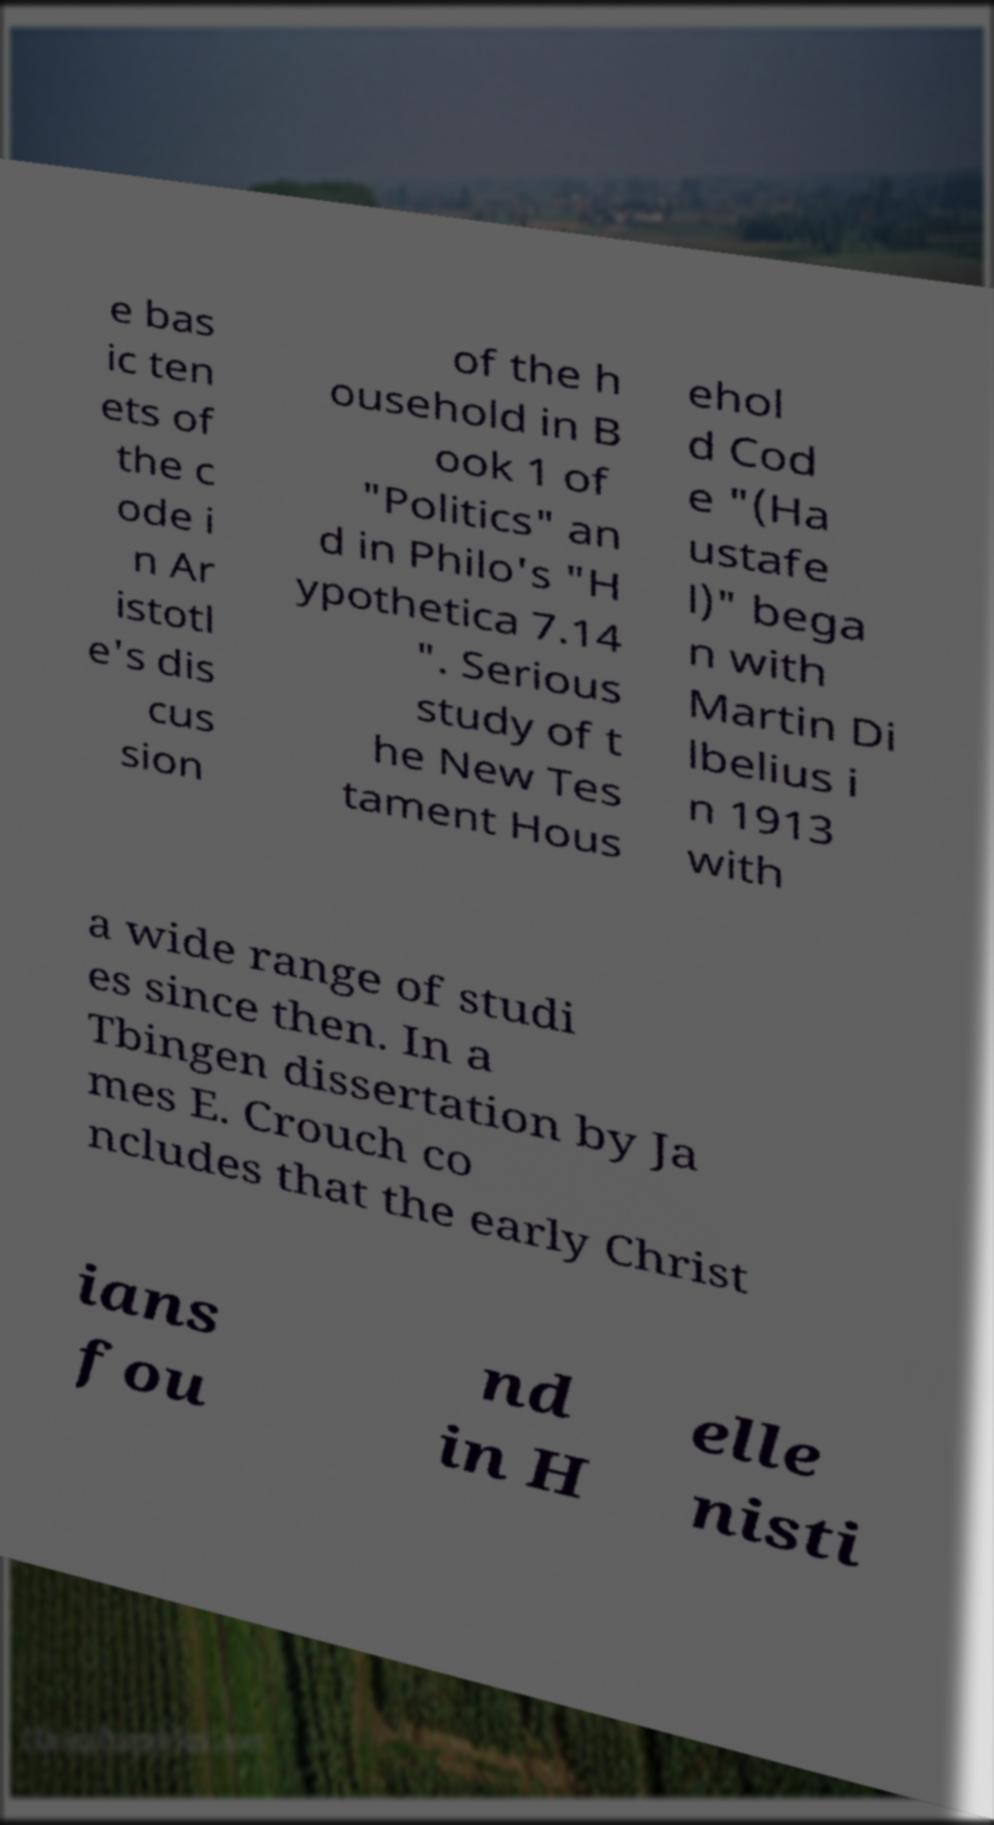There's text embedded in this image that I need extracted. Can you transcribe it verbatim? e bas ic ten ets of the c ode i n Ar istotl e's dis cus sion of the h ousehold in B ook 1 of "Politics" an d in Philo's "H ypothetica 7.14 ". Serious study of t he New Tes tament Hous ehol d Cod e "(Ha ustafe l)" bega n with Martin Di lbelius i n 1913 with a wide range of studi es since then. In a Tbingen dissertation by Ja mes E. Crouch co ncludes that the early Christ ians fou nd in H elle nisti 